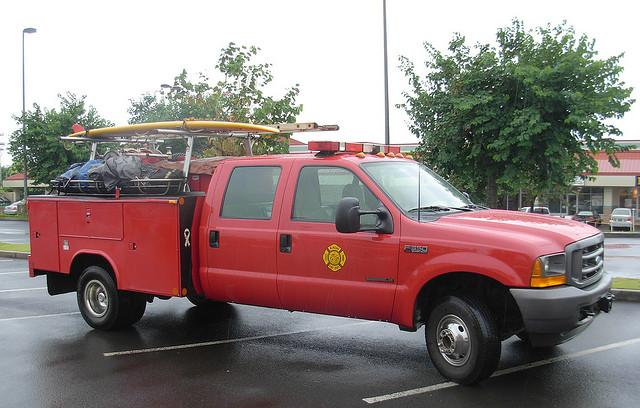What is this vehicle used for?

Choices:
A) hauling
B) construction
C) emergencies
D) passengers emergencies 